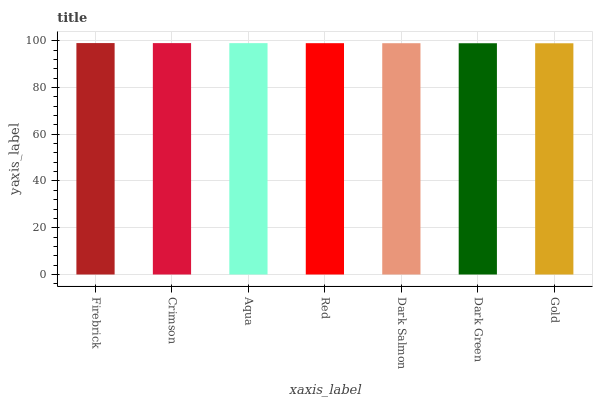Is Gold the minimum?
Answer yes or no. Yes. Is Firebrick the maximum?
Answer yes or no. Yes. Is Crimson the minimum?
Answer yes or no. No. Is Crimson the maximum?
Answer yes or no. No. Is Firebrick greater than Crimson?
Answer yes or no. Yes. Is Crimson less than Firebrick?
Answer yes or no. Yes. Is Crimson greater than Firebrick?
Answer yes or no. No. Is Firebrick less than Crimson?
Answer yes or no. No. Is Red the high median?
Answer yes or no. Yes. Is Red the low median?
Answer yes or no. Yes. Is Dark Salmon the high median?
Answer yes or no. No. Is Crimson the low median?
Answer yes or no. No. 